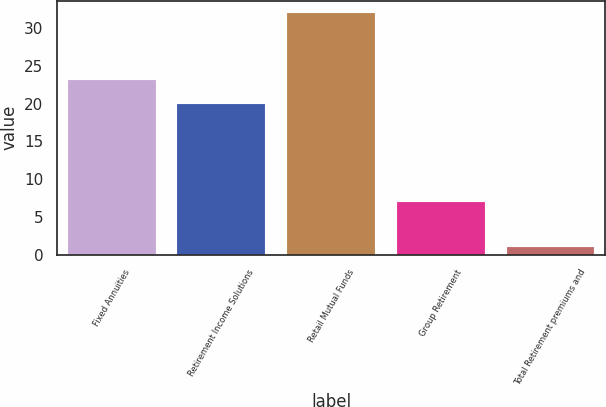Convert chart to OTSL. <chart><loc_0><loc_0><loc_500><loc_500><bar_chart><fcel>Fixed Annuities<fcel>Retirement Income Solutions<fcel>Retail Mutual Funds<fcel>Group Retirement<fcel>Total Retirement premiums and<nl><fcel>23.1<fcel>20<fcel>32<fcel>7<fcel>1<nl></chart> 